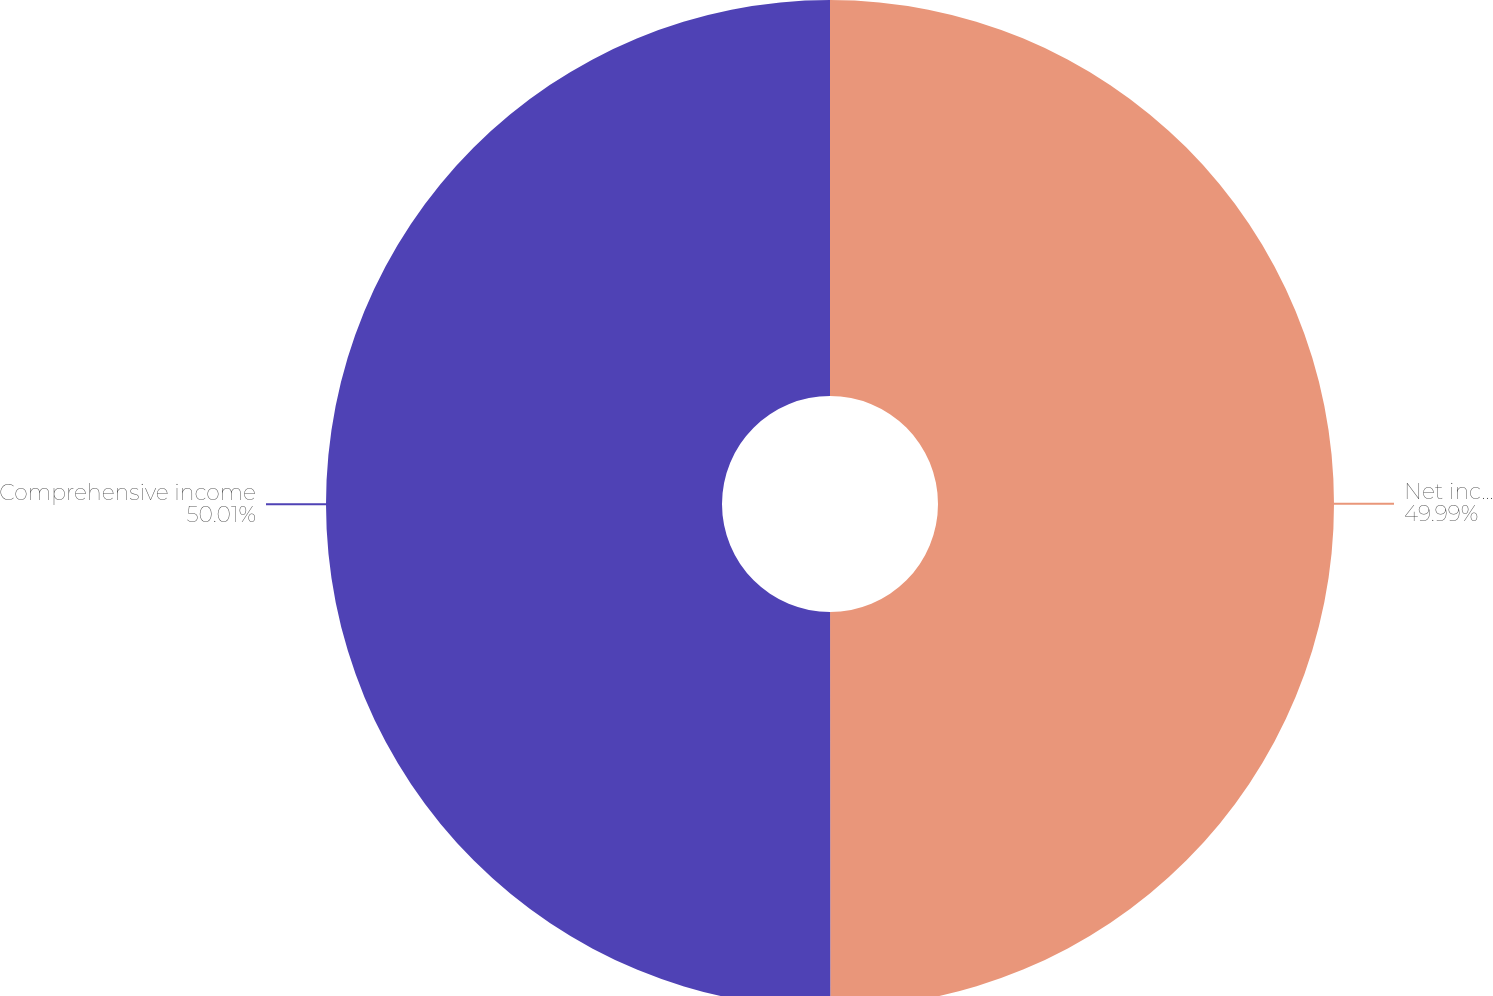Convert chart. <chart><loc_0><loc_0><loc_500><loc_500><pie_chart><fcel>Net income<fcel>Comprehensive income<nl><fcel>49.99%<fcel>50.01%<nl></chart> 